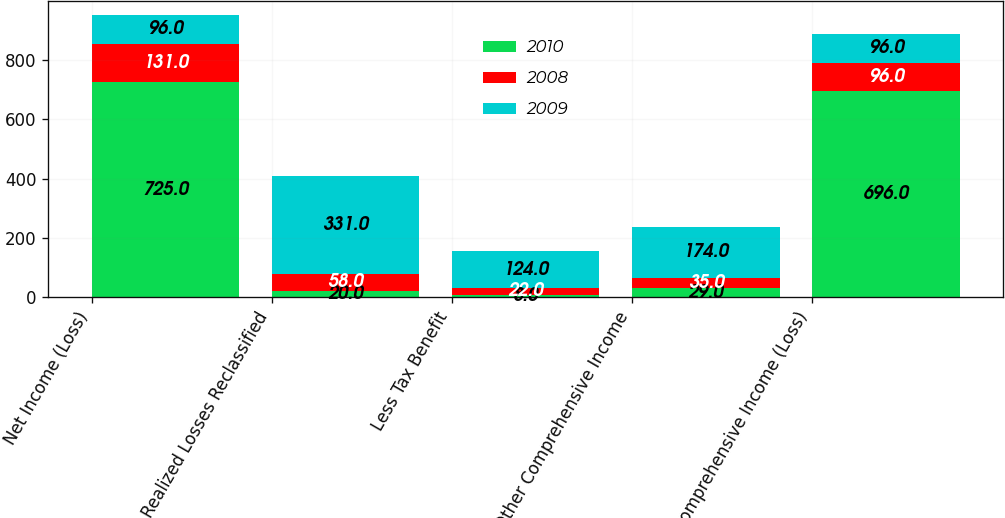<chart> <loc_0><loc_0><loc_500><loc_500><stacked_bar_chart><ecel><fcel>Net Income (Loss)<fcel>Realized Losses Reclassified<fcel>Less Tax Benefit<fcel>Other Comprehensive Income<fcel>Comprehensive Income (Loss)<nl><fcel>2010<fcel>725<fcel>20<fcel>8<fcel>29<fcel>696<nl><fcel>2008<fcel>131<fcel>58<fcel>22<fcel>35<fcel>96<nl><fcel>2009<fcel>96<fcel>331<fcel>124<fcel>174<fcel>96<nl></chart> 